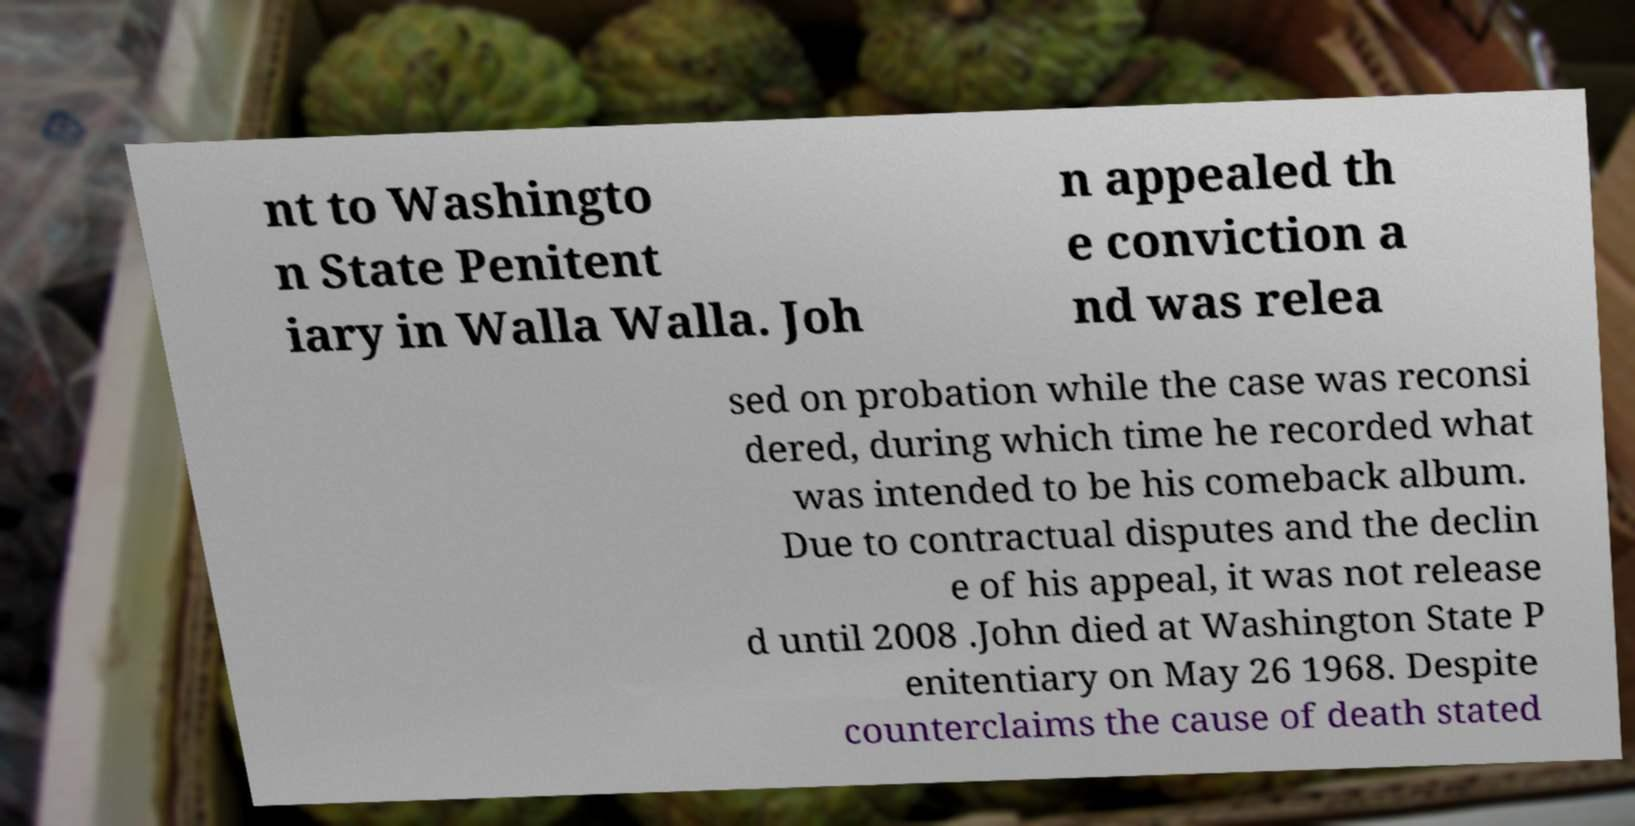Can you read and provide the text displayed in the image?This photo seems to have some interesting text. Can you extract and type it out for me? nt to Washingto n State Penitent iary in Walla Walla. Joh n appealed th e conviction a nd was relea sed on probation while the case was reconsi dered, during which time he recorded what was intended to be his comeback album. Due to contractual disputes and the declin e of his appeal, it was not release d until 2008 .John died at Washington State P enitentiary on May 26 1968. Despite counterclaims the cause of death stated 